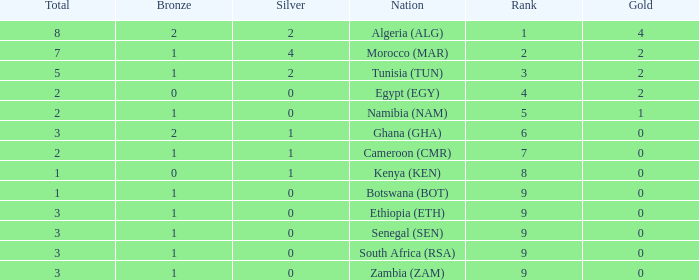What is the lowest Bronze with a Nation of egypt (egy) and with a Gold that is smaller than 2? None. 